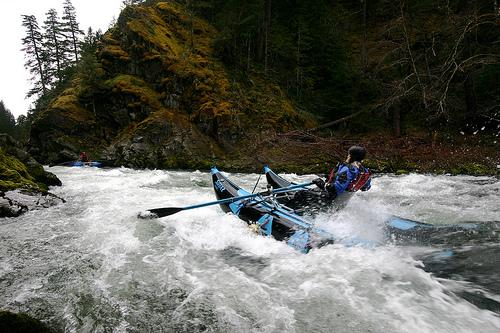Provide a succinct description of the person, their activity, and the surrounding environment in the image. A rafter in blue apparel engages in white water rafting on a fast-flowing river, surrounded by a lush green landscape. Give a short overview of the primary object and its environment in the image. A person white water rafting in a blue raft with a helmet, surrounded by green trees, mossy rocks, and flowing water. Mention the primary focus of the image and the activity taking place. A person is engaged in white water rafting on a river surrounded by lush green vegetation and picturesque scenery. In a few words, describe the central figure in the picture and the action they are undertaking. A person in blue gear white water rafting on a swift river amidst a vibrant, green natural setting. Describe the key components and actions in the image in a concise manner. A rafter wearing a blue jacket and helmet tackles white water rapids on a river with green vegetation and rocky surroundings. Elaborate on the main subject of the image, their attire, and the activity they are participating in. A rafter dressed in a blue jacket, black helmet, and red backpack is white water rafting in a blue and black raft amidst a beautiful landscape. Provide a brief description of the scene in the image focusing on colors and surroundings. A daytime scene featuring a person in a blue jacket white water rafting on a fast-flowing river, with green trees and moss-covered rocks around. Offer a brief account of the image's main subject and the ongoing activity. An individual wearing a blue jacket and a helmet is white water rafting through rapids, surrounded by green trees and rocks. Summarize the main elements in the picture, including the individual, their activity, and the location. A white water rafter in a blue jacket navigates rapids on a river amid green trees, large rocks, and a hill in the distance. Quickly summarize the person's appearance and their actions within the context of the image. A helmeted rafter in a blue jacket is navigating white water rapids in a picturesque river setting with greenery and rocks. 